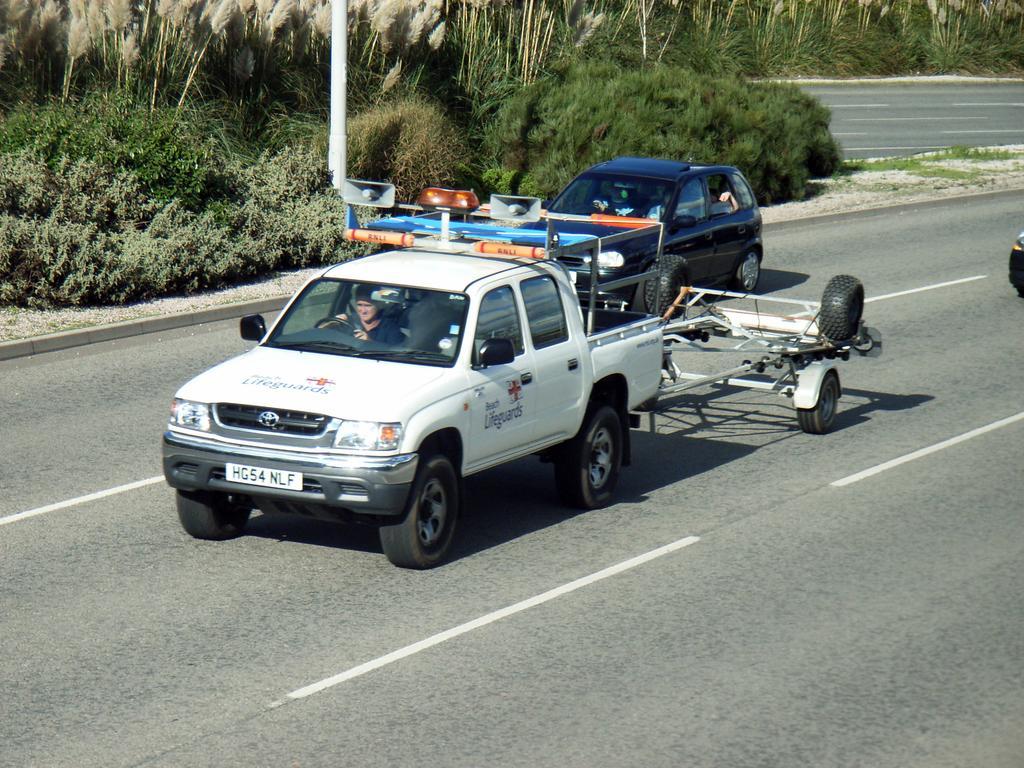Can you describe this image briefly? In this image, there is a road, we can see two cars on the road, we can see some green color plants and trees. 